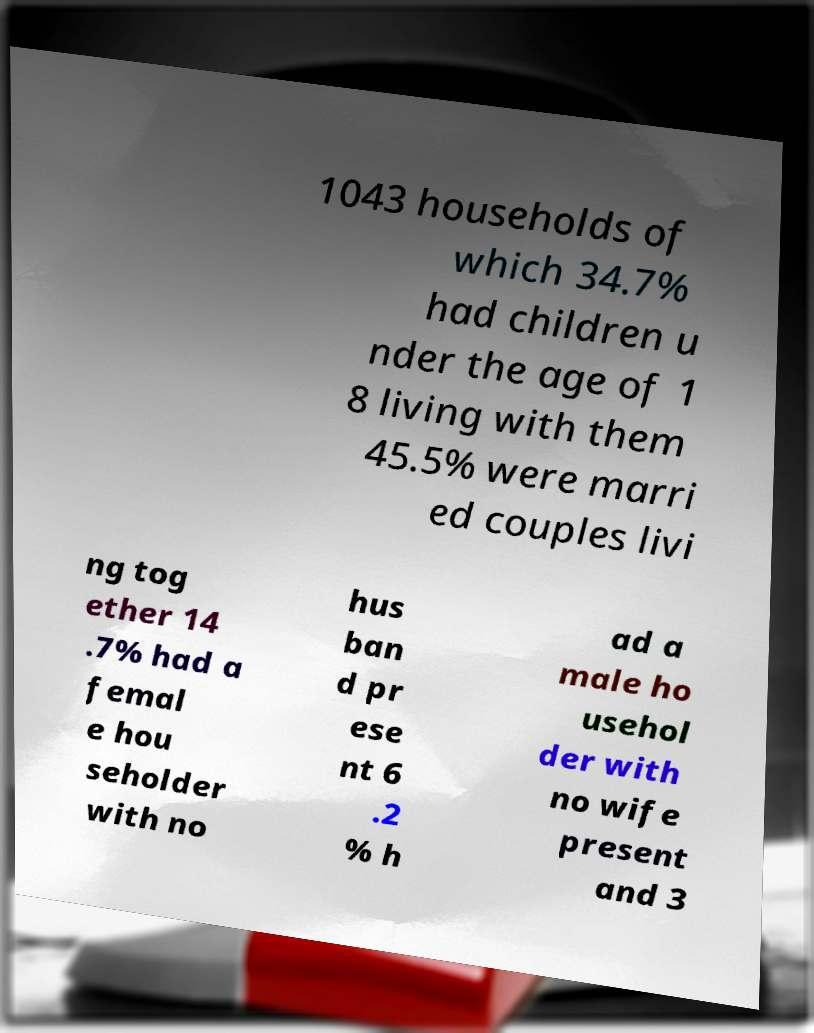Please identify and transcribe the text found in this image. 1043 households of which 34.7% had children u nder the age of 1 8 living with them 45.5% were marri ed couples livi ng tog ether 14 .7% had a femal e hou seholder with no hus ban d pr ese nt 6 .2 % h ad a male ho usehol der with no wife present and 3 